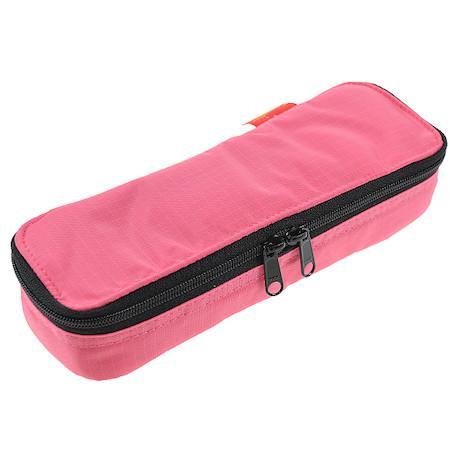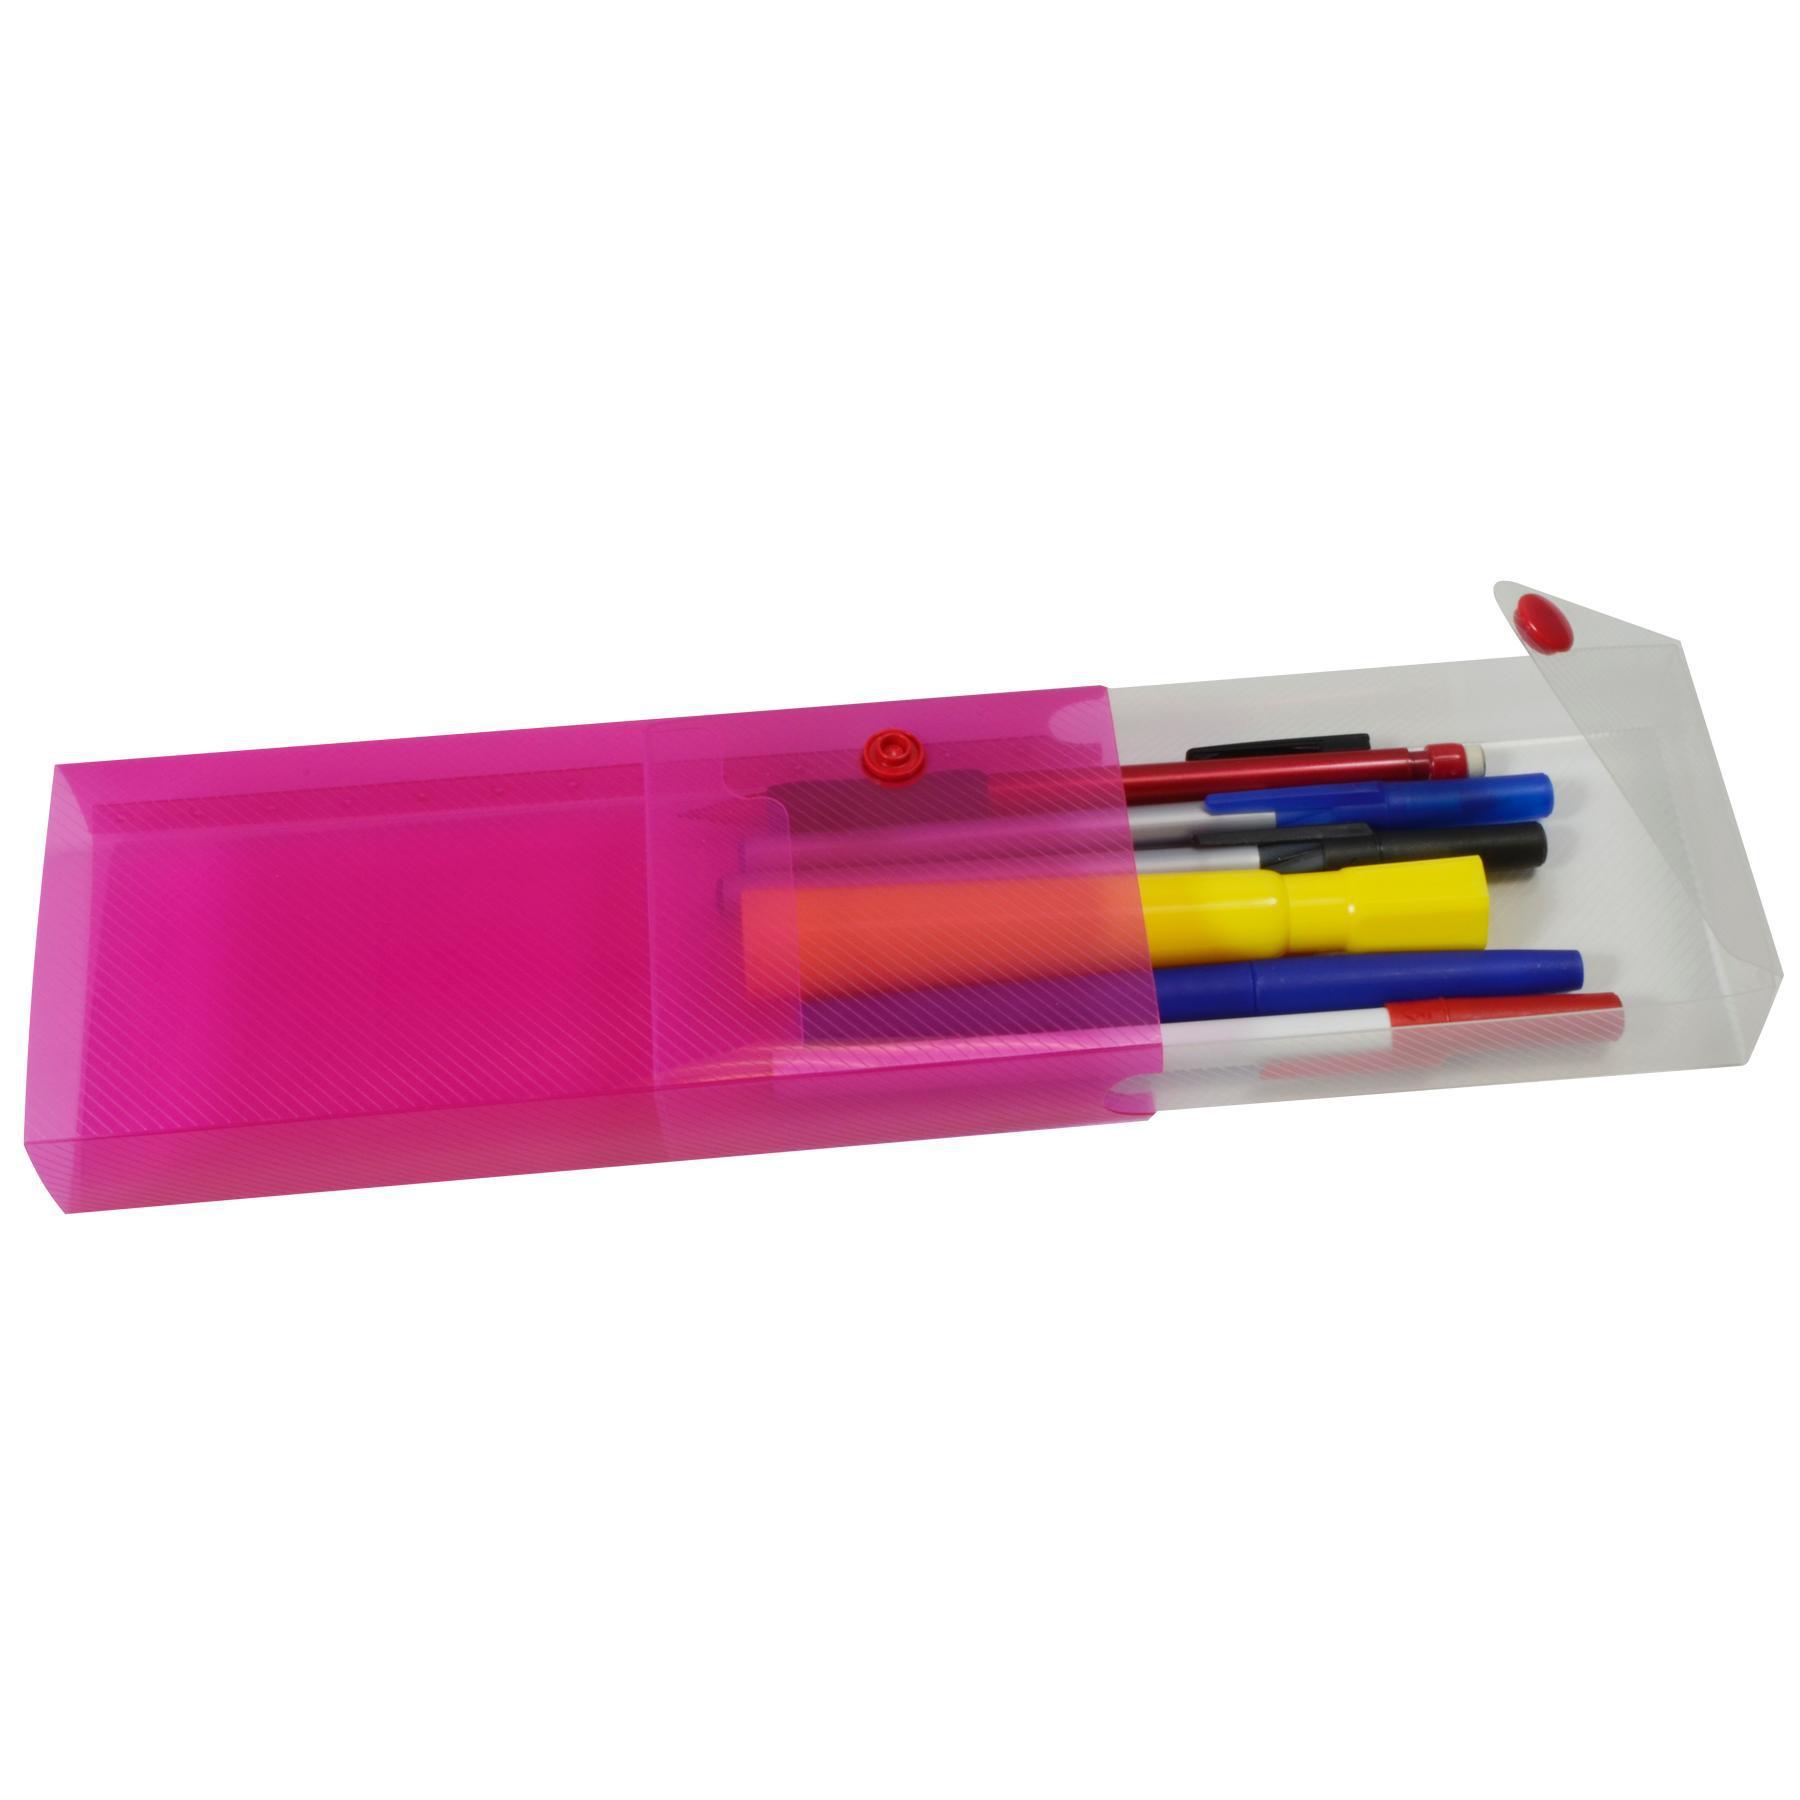The first image is the image on the left, the second image is the image on the right. Assess this claim about the two images: "Two pencil cases with top zippers are different sizes and only one has a visible tag affixed.". Correct or not? Answer yes or no. No. The first image is the image on the left, the second image is the image on the right. For the images shown, is this caption "One case is solid color and rectangular with rounded edges, and has two zipper pulls on top to zip the case open, and the other case features a bright warm color." true? Answer yes or no. Yes. 